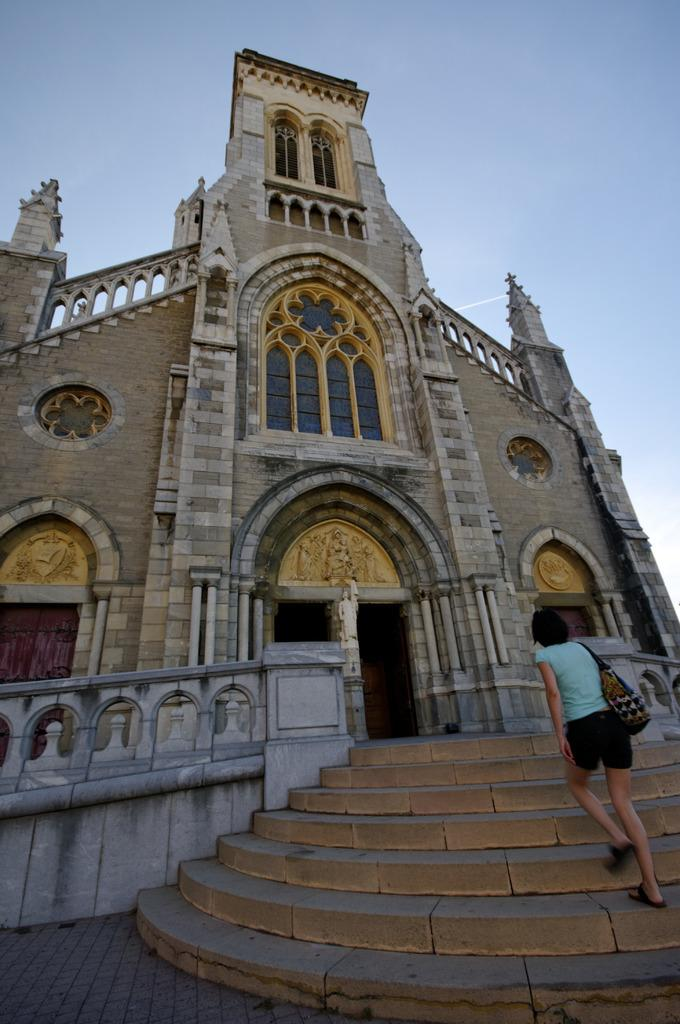Who is the main subject in the image? There is a girl in the image. What is the girl wearing in the image? The girl is wearing a handbag in the image. What is the girl doing in the image? The girl is walking in the image. Where is the girl heading in the image? The girl is approaching the entrance of a building in the image. Can you see any ducks swimming in a stream in the image? There are no ducks or streams present in the image. 